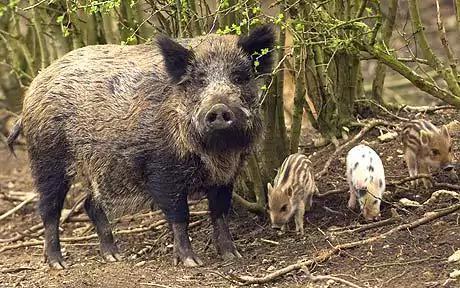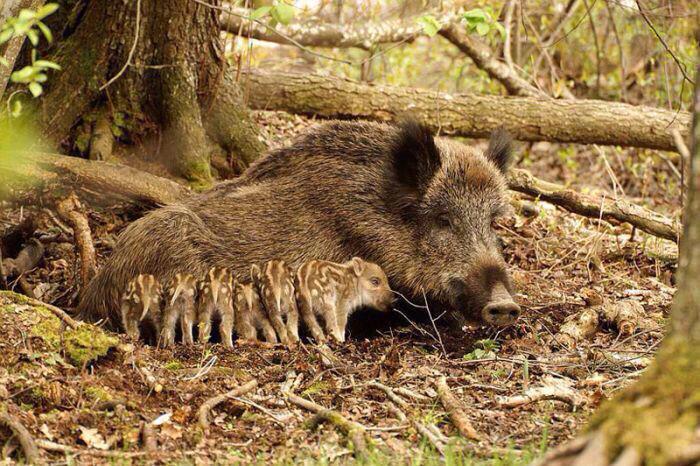The first image is the image on the left, the second image is the image on the right. Considering the images on both sides, is "Piglets are standing beside an adult pig in both images." valid? Answer yes or no. Yes. The first image is the image on the left, the second image is the image on the right. Given the left and right images, does the statement "The left image contains no more than five wild boars." hold true? Answer yes or no. Yes. 